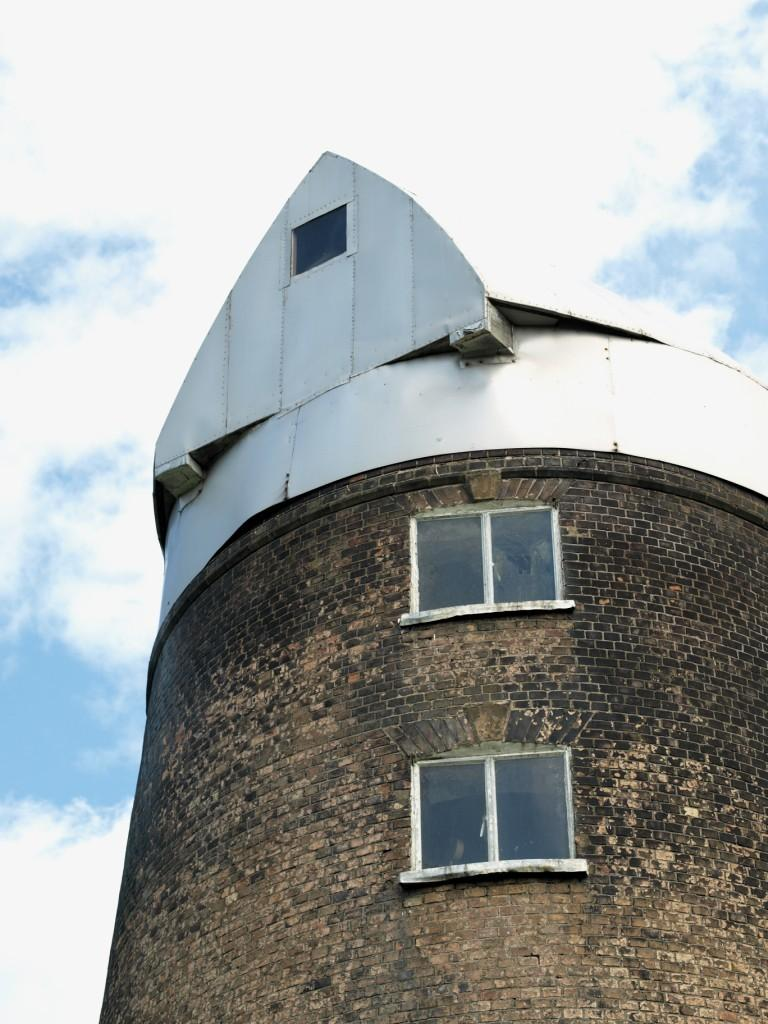Where was the image taken? The image was taken outdoors. What can be seen in the sky in the image? The sky with clouds is visible at the top of the image. What structure is located on the right side of the image? There is a building on the right side of the image. What are the main features of the building? The building has walls, windows, and a roof. What type of sack is being used to carry coal in the image? There is no sack or coal present in the image. How many pins are visible on the building in the image? There are no pins visible on the building in the image. 